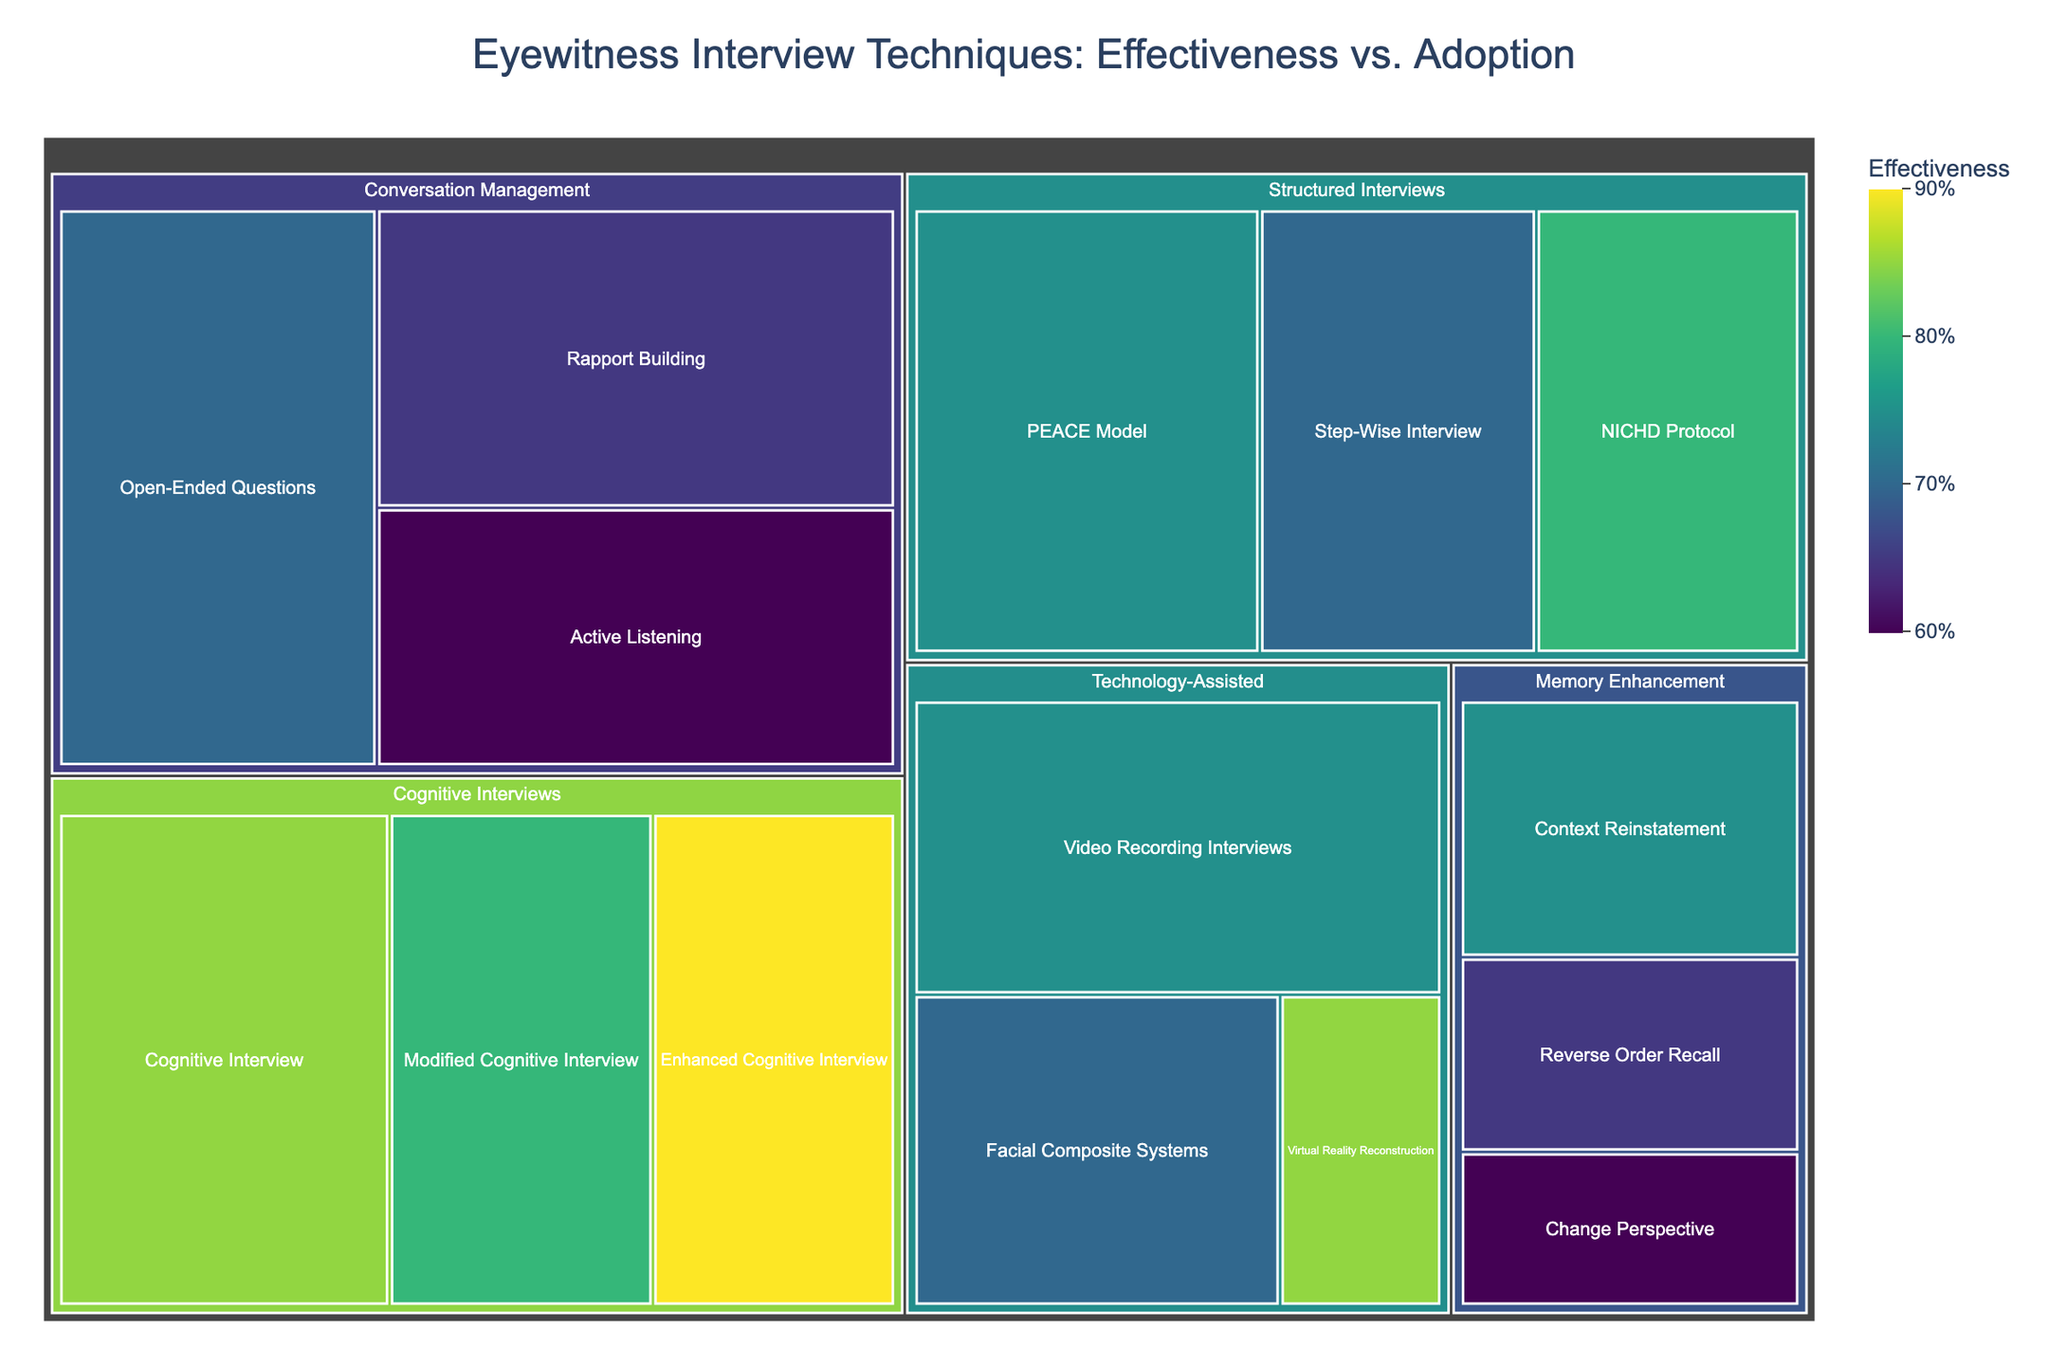what is the category with the highest adopted technique? The technique “Open-Ended Questions” falls under “Conversation Management” and has the highest adoption rate of 85%. Thus, "Conversation Management" has the highest adopted technique.
Answer: Conversation Management What are the three techniques under "Memory Enhancement"? The “Memory Enhancement” category consists of three techniques: “Context Reinstatement,” “Reverse Order Recall,” and “Change Perspective.” By examining the sections within the “Memory Enhancement” area, you can identify each technique.
Answer: "Context Reinstatement", "Reverse Order Recall", "Change Perspective" Which category has the most effective technique? To determine the category with the most effective technique, look for the highest effectiveness value. The “Enhanced Cognitive Interview” in the “Cognitive Interviews” category has an effectiveness of 90%, which is the highest.
Answer: Cognitive Interviews Compare the adoption rate of "Virtual Reality Reconstruction" and "Facial Composite Systems". Which is higher? By examining the specific sections for "Virtual Reality Reconstruction" and "Facial Composite Systems" within the "Technology-Assisted" category, we find the adoption rates of 20% and 55%, respectively. Hence, "Facial Composite Systems" has a higher adoption rate.
Answer: Facial Composite Systems What is the combined effectiveness of “Rapport Building” and “Active Listening”? The effectiveness of “Rapport Building” is 65% and “Active Listening” is 60%. Their combined effectiveness is 65 + 60 = 125.
Answer: 125 Which technique in the “Structured Interviews” category has the highest adoption rate and what is it? In the “Structured Interviews” category, the “PEACE Model” has the highest adoption rate at 70%. This is identified by examining the adoption rates of all techniques within this category.
Answer: PEACE Model What's the color indication for the most effective technique? The most effective technique, “Enhanced Cognitive Interview,” has an effectiveness of 90%. In the Viridis color scale, this section would appear towards the lighter end of the green spectrum, typically a bright yellow-green shade.
Answer: Bright yellow-green How does the adoption rate of "Video Recording Interviews" compare to "Step-Wise Interview"? "Video Recording Interviews" has an adoption rate of 70% while "Step-Wise Interview" has 60%. Comparing these figures, “Video Recording Interviews” has a higher adoption rate.
Answer: "Video Recording Interviews" is higher 